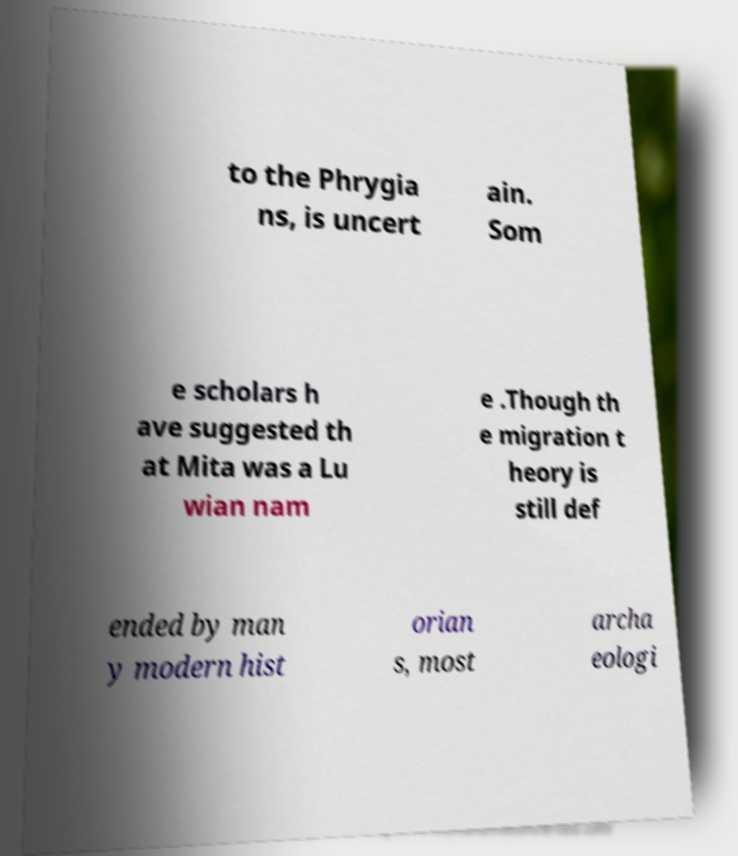I need the written content from this picture converted into text. Can you do that? to the Phrygia ns, is uncert ain. Som e scholars h ave suggested th at Mita was a Lu wian nam e .Though th e migration t heory is still def ended by man y modern hist orian s, most archa eologi 